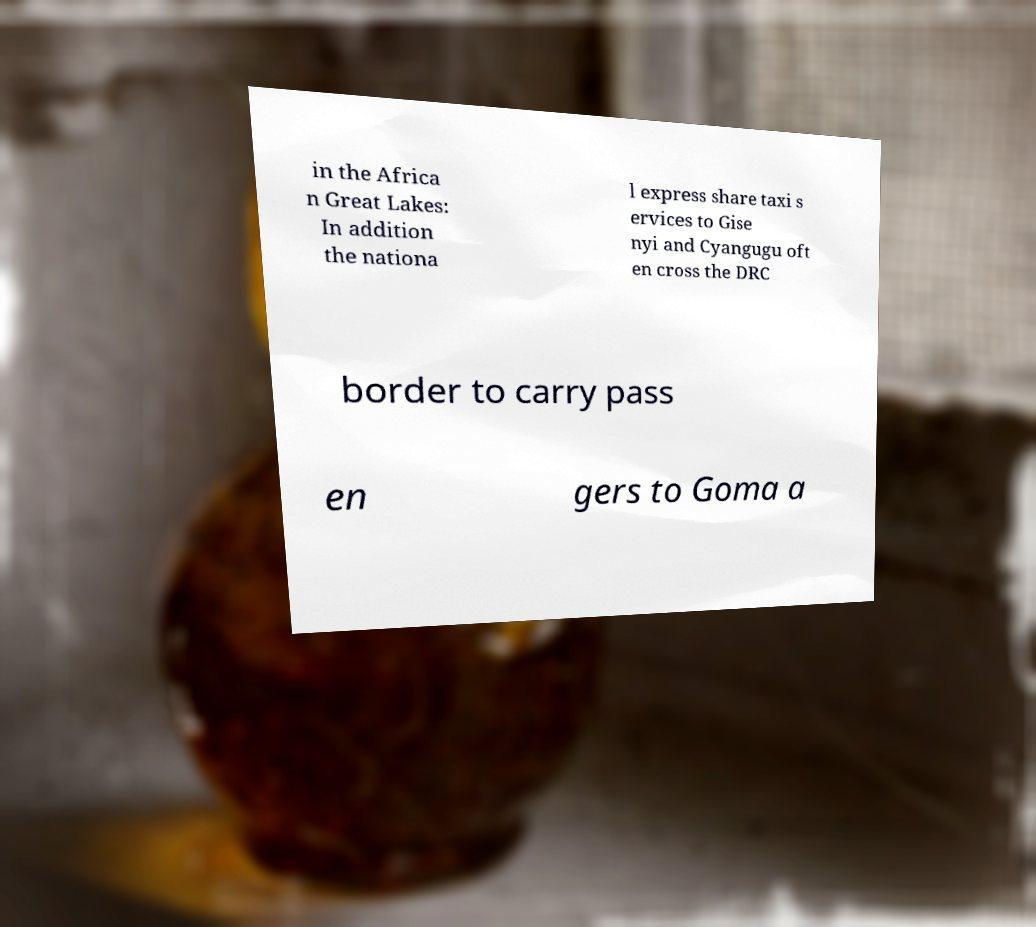Can you read and provide the text displayed in the image?This photo seems to have some interesting text. Can you extract and type it out for me? in the Africa n Great Lakes: In addition the nationa l express share taxi s ervices to Gise nyi and Cyangugu oft en cross the DRC border to carry pass en gers to Goma a 